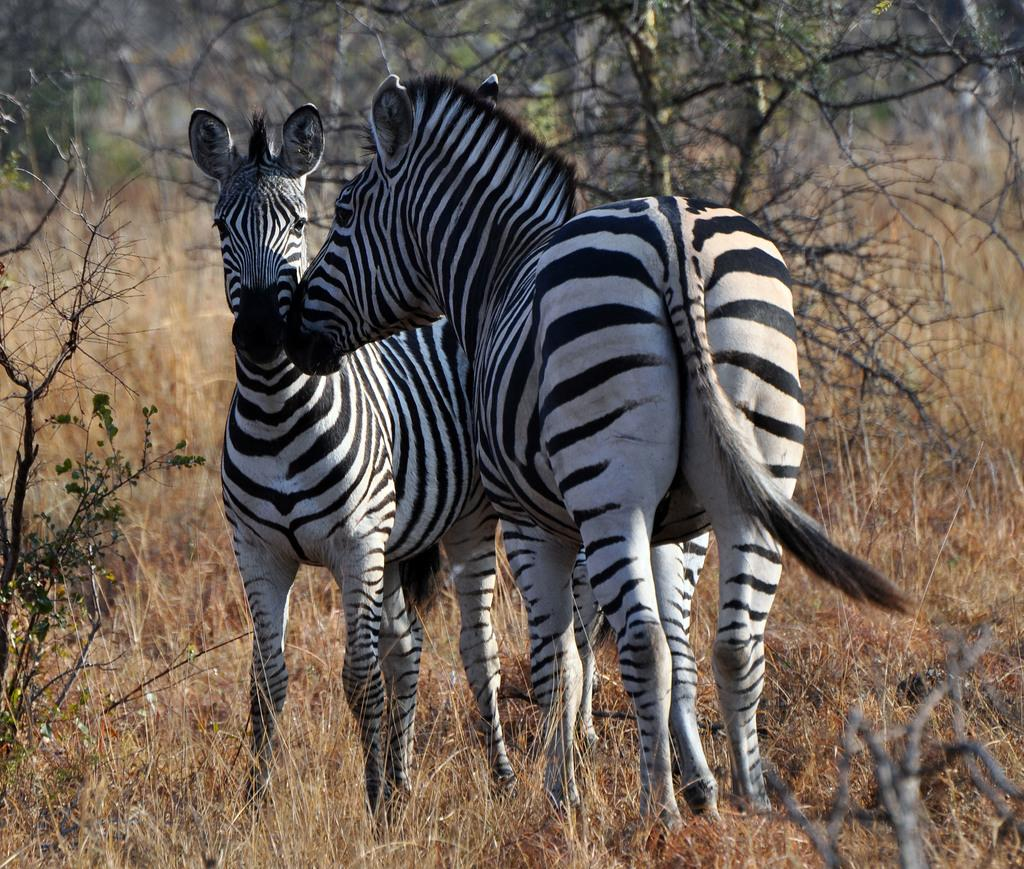What type of vegetation can be seen in the image? There are branches and green leaves in the image. What type of animals are present in the image? There are zebras in the image. What type of ground cover is visible in the image? There is grass in the image. What type of print can be seen on the zebras in the image? There is no print visible on the zebras in the image; they have natural stripes. 